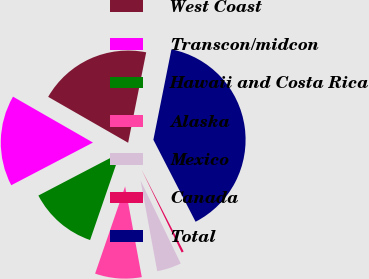Convert chart. <chart><loc_0><loc_0><loc_500><loc_500><pie_chart><fcel>West Coast<fcel>Transcon/midcon<fcel>Hawaii and Costa Rica<fcel>Alaska<fcel>Mexico<fcel>Canada<fcel>Total<nl><fcel>19.84%<fcel>15.95%<fcel>12.06%<fcel>8.17%<fcel>4.28%<fcel>0.39%<fcel>39.29%<nl></chart> 